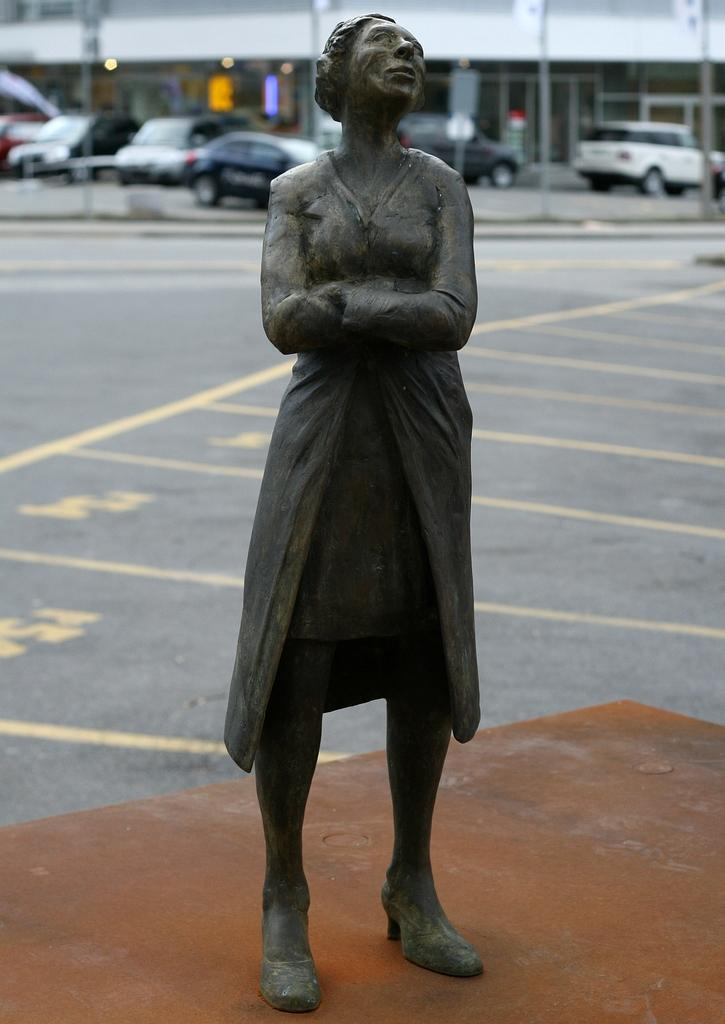What is the main subject of the image? There is a statue in the image. Where is the statue located? The statue is on a platform. What can be seen in the background of the image? There is a road, vehicles, buildings, lights, and poles visible in the background of the image. Can you describe the unspecified objects in the background? Unfortunately, the facts provided do not specify the nature of the unspecified objects in the background. What type of cord is the mother using to hold her baby's finger in the image? There is no mother, baby, or cord present in the image. 